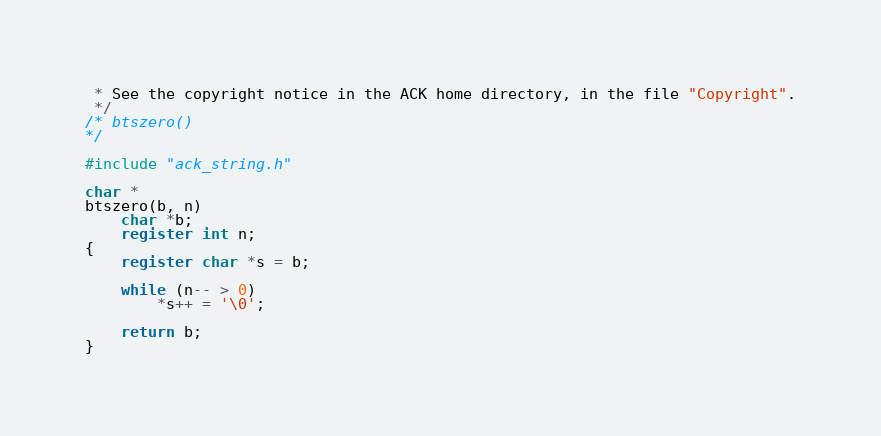Convert code to text. <code><loc_0><loc_0><loc_500><loc_500><_C_> * See the copyright notice in the ACK home directory, in the file "Copyright".
 */
/* btszero()
*/

#include "ack_string.h"

char *
btszero(b, n)
	char *b;
	register int n;
{
	register char *s = b;

	while (n-- > 0)
		*s++ = '\0';
	
	return b;
}
</code> 